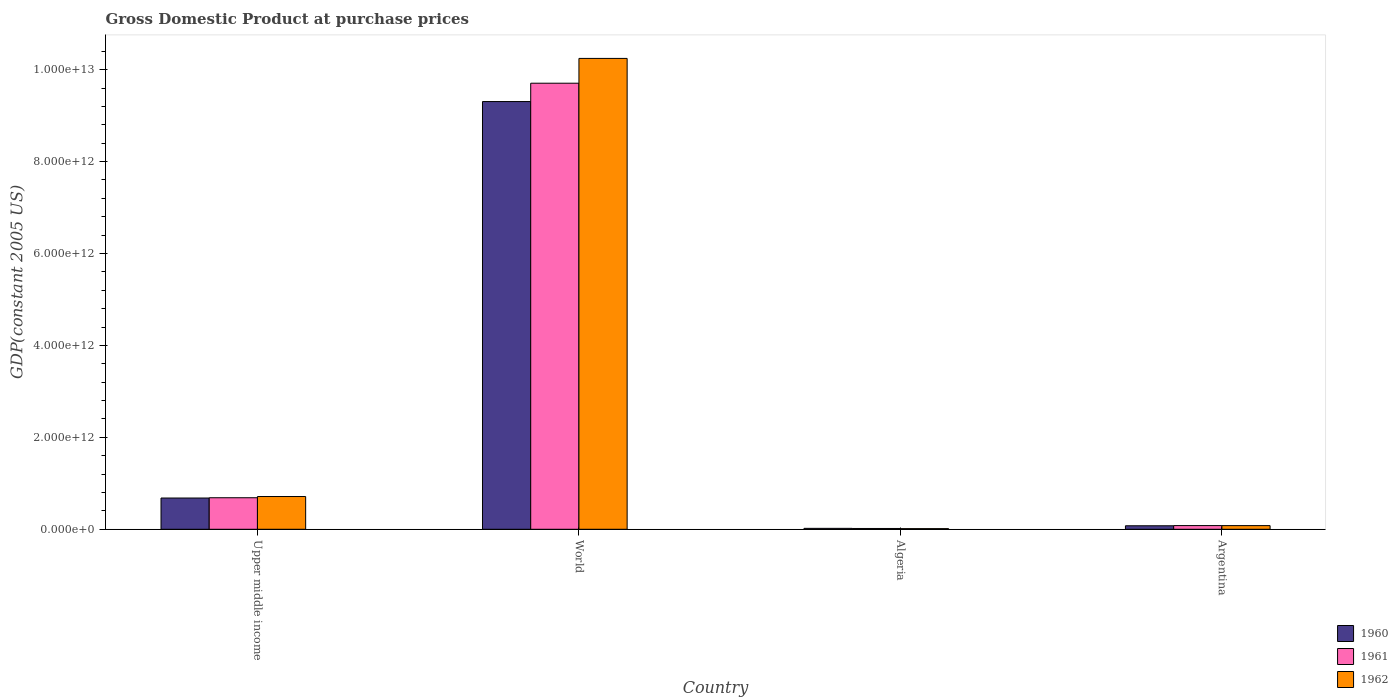How many groups of bars are there?
Offer a very short reply. 4. Are the number of bars per tick equal to the number of legend labels?
Give a very brief answer. Yes. In how many cases, is the number of bars for a given country not equal to the number of legend labels?
Provide a succinct answer. 0. What is the GDP at purchase prices in 1961 in World?
Provide a short and direct response. 9.71e+12. Across all countries, what is the maximum GDP at purchase prices in 1962?
Give a very brief answer. 1.02e+13. Across all countries, what is the minimum GDP at purchase prices in 1961?
Offer a terse response. 1.72e+1. In which country was the GDP at purchase prices in 1960 maximum?
Your answer should be compact. World. In which country was the GDP at purchase prices in 1960 minimum?
Make the answer very short. Algeria. What is the total GDP at purchase prices in 1961 in the graph?
Ensure brevity in your answer.  1.05e+13. What is the difference between the GDP at purchase prices in 1960 in Algeria and that in World?
Your answer should be very brief. -9.29e+12. What is the difference between the GDP at purchase prices in 1961 in Upper middle income and the GDP at purchase prices in 1960 in World?
Ensure brevity in your answer.  -8.62e+12. What is the average GDP at purchase prices in 1962 per country?
Your response must be concise. 2.76e+12. What is the difference between the GDP at purchase prices of/in 1960 and GDP at purchase prices of/in 1961 in Argentina?
Provide a succinct answer. -4.14e+09. In how many countries, is the GDP at purchase prices in 1962 greater than 2800000000000 US$?
Your answer should be very brief. 1. What is the ratio of the GDP at purchase prices in 1962 in Argentina to that in World?
Provide a succinct answer. 0.01. What is the difference between the highest and the second highest GDP at purchase prices in 1962?
Your answer should be compact. 1.02e+13. What is the difference between the highest and the lowest GDP at purchase prices in 1960?
Offer a very short reply. 9.29e+12. In how many countries, is the GDP at purchase prices in 1960 greater than the average GDP at purchase prices in 1960 taken over all countries?
Make the answer very short. 1. What is the difference between two consecutive major ticks on the Y-axis?
Your answer should be compact. 2.00e+12. Does the graph contain any zero values?
Offer a terse response. No. How many legend labels are there?
Your answer should be compact. 3. How are the legend labels stacked?
Provide a succinct answer. Vertical. What is the title of the graph?
Offer a very short reply. Gross Domestic Product at purchase prices. What is the label or title of the Y-axis?
Provide a succinct answer. GDP(constant 2005 US). What is the GDP(constant 2005 US) in 1960 in Upper middle income?
Offer a terse response. 6.80e+11. What is the GDP(constant 2005 US) of 1961 in Upper middle income?
Provide a succinct answer. 6.86e+11. What is the GDP(constant 2005 US) in 1962 in Upper middle income?
Provide a short and direct response. 7.13e+11. What is the GDP(constant 2005 US) of 1960 in World?
Your response must be concise. 9.31e+12. What is the GDP(constant 2005 US) in 1961 in World?
Your answer should be compact. 9.71e+12. What is the GDP(constant 2005 US) in 1962 in World?
Offer a terse response. 1.02e+13. What is the GDP(constant 2005 US) of 1960 in Algeria?
Give a very brief answer. 1.99e+1. What is the GDP(constant 2005 US) of 1961 in Algeria?
Keep it short and to the point. 1.72e+1. What is the GDP(constant 2005 US) of 1962 in Algeria?
Give a very brief answer. 1.38e+1. What is the GDP(constant 2005 US) in 1960 in Argentina?
Your answer should be very brief. 7.63e+1. What is the GDP(constant 2005 US) of 1961 in Argentina?
Provide a succinct answer. 8.04e+1. What is the GDP(constant 2005 US) in 1962 in Argentina?
Your answer should be very brief. 7.97e+1. Across all countries, what is the maximum GDP(constant 2005 US) of 1960?
Give a very brief answer. 9.31e+12. Across all countries, what is the maximum GDP(constant 2005 US) of 1961?
Keep it short and to the point. 9.71e+12. Across all countries, what is the maximum GDP(constant 2005 US) of 1962?
Ensure brevity in your answer.  1.02e+13. Across all countries, what is the minimum GDP(constant 2005 US) of 1960?
Offer a terse response. 1.99e+1. Across all countries, what is the minimum GDP(constant 2005 US) of 1961?
Provide a short and direct response. 1.72e+1. Across all countries, what is the minimum GDP(constant 2005 US) in 1962?
Provide a short and direct response. 1.38e+1. What is the total GDP(constant 2005 US) of 1960 in the graph?
Keep it short and to the point. 1.01e+13. What is the total GDP(constant 2005 US) of 1961 in the graph?
Your answer should be compact. 1.05e+13. What is the total GDP(constant 2005 US) of 1962 in the graph?
Give a very brief answer. 1.11e+13. What is the difference between the GDP(constant 2005 US) in 1960 in Upper middle income and that in World?
Make the answer very short. -8.63e+12. What is the difference between the GDP(constant 2005 US) in 1961 in Upper middle income and that in World?
Your answer should be compact. -9.02e+12. What is the difference between the GDP(constant 2005 US) of 1962 in Upper middle income and that in World?
Give a very brief answer. -9.53e+12. What is the difference between the GDP(constant 2005 US) of 1960 in Upper middle income and that in Algeria?
Make the answer very short. 6.60e+11. What is the difference between the GDP(constant 2005 US) in 1961 in Upper middle income and that in Algeria?
Provide a succinct answer. 6.69e+11. What is the difference between the GDP(constant 2005 US) of 1962 in Upper middle income and that in Algeria?
Your response must be concise. 6.99e+11. What is the difference between the GDP(constant 2005 US) in 1960 in Upper middle income and that in Argentina?
Offer a very short reply. 6.04e+11. What is the difference between the GDP(constant 2005 US) of 1961 in Upper middle income and that in Argentina?
Make the answer very short. 6.06e+11. What is the difference between the GDP(constant 2005 US) of 1962 in Upper middle income and that in Argentina?
Offer a terse response. 6.33e+11. What is the difference between the GDP(constant 2005 US) in 1960 in World and that in Algeria?
Provide a succinct answer. 9.29e+12. What is the difference between the GDP(constant 2005 US) in 1961 in World and that in Algeria?
Your response must be concise. 9.69e+12. What is the difference between the GDP(constant 2005 US) of 1962 in World and that in Algeria?
Ensure brevity in your answer.  1.02e+13. What is the difference between the GDP(constant 2005 US) in 1960 in World and that in Argentina?
Offer a terse response. 9.23e+12. What is the difference between the GDP(constant 2005 US) of 1961 in World and that in Argentina?
Provide a succinct answer. 9.63e+12. What is the difference between the GDP(constant 2005 US) of 1962 in World and that in Argentina?
Offer a very short reply. 1.02e+13. What is the difference between the GDP(constant 2005 US) in 1960 in Algeria and that in Argentina?
Make the answer very short. -5.63e+1. What is the difference between the GDP(constant 2005 US) of 1961 in Algeria and that in Argentina?
Provide a short and direct response. -6.32e+1. What is the difference between the GDP(constant 2005 US) of 1962 in Algeria and that in Argentina?
Give a very brief answer. -6.59e+1. What is the difference between the GDP(constant 2005 US) in 1960 in Upper middle income and the GDP(constant 2005 US) in 1961 in World?
Offer a terse response. -9.03e+12. What is the difference between the GDP(constant 2005 US) in 1960 in Upper middle income and the GDP(constant 2005 US) in 1962 in World?
Your answer should be very brief. -9.56e+12. What is the difference between the GDP(constant 2005 US) in 1961 in Upper middle income and the GDP(constant 2005 US) in 1962 in World?
Your response must be concise. -9.56e+12. What is the difference between the GDP(constant 2005 US) in 1960 in Upper middle income and the GDP(constant 2005 US) in 1961 in Algeria?
Ensure brevity in your answer.  6.63e+11. What is the difference between the GDP(constant 2005 US) in 1960 in Upper middle income and the GDP(constant 2005 US) in 1962 in Algeria?
Provide a succinct answer. 6.66e+11. What is the difference between the GDP(constant 2005 US) of 1961 in Upper middle income and the GDP(constant 2005 US) of 1962 in Algeria?
Provide a succinct answer. 6.72e+11. What is the difference between the GDP(constant 2005 US) of 1960 in Upper middle income and the GDP(constant 2005 US) of 1961 in Argentina?
Give a very brief answer. 6.00e+11. What is the difference between the GDP(constant 2005 US) of 1960 in Upper middle income and the GDP(constant 2005 US) of 1962 in Argentina?
Offer a terse response. 6.00e+11. What is the difference between the GDP(constant 2005 US) in 1961 in Upper middle income and the GDP(constant 2005 US) in 1962 in Argentina?
Provide a succinct answer. 6.06e+11. What is the difference between the GDP(constant 2005 US) of 1960 in World and the GDP(constant 2005 US) of 1961 in Algeria?
Your answer should be compact. 9.29e+12. What is the difference between the GDP(constant 2005 US) in 1960 in World and the GDP(constant 2005 US) in 1962 in Algeria?
Give a very brief answer. 9.29e+12. What is the difference between the GDP(constant 2005 US) in 1961 in World and the GDP(constant 2005 US) in 1962 in Algeria?
Provide a short and direct response. 9.69e+12. What is the difference between the GDP(constant 2005 US) in 1960 in World and the GDP(constant 2005 US) in 1961 in Argentina?
Provide a short and direct response. 9.23e+12. What is the difference between the GDP(constant 2005 US) of 1960 in World and the GDP(constant 2005 US) of 1962 in Argentina?
Make the answer very short. 9.23e+12. What is the difference between the GDP(constant 2005 US) in 1961 in World and the GDP(constant 2005 US) in 1962 in Argentina?
Keep it short and to the point. 9.63e+12. What is the difference between the GDP(constant 2005 US) of 1960 in Algeria and the GDP(constant 2005 US) of 1961 in Argentina?
Give a very brief answer. -6.05e+1. What is the difference between the GDP(constant 2005 US) of 1960 in Algeria and the GDP(constant 2005 US) of 1962 in Argentina?
Offer a very short reply. -5.98e+1. What is the difference between the GDP(constant 2005 US) in 1961 in Algeria and the GDP(constant 2005 US) in 1962 in Argentina?
Offer a terse response. -6.25e+1. What is the average GDP(constant 2005 US) of 1960 per country?
Ensure brevity in your answer.  2.52e+12. What is the average GDP(constant 2005 US) in 1961 per country?
Your answer should be very brief. 2.62e+12. What is the average GDP(constant 2005 US) of 1962 per country?
Your answer should be very brief. 2.76e+12. What is the difference between the GDP(constant 2005 US) of 1960 and GDP(constant 2005 US) of 1961 in Upper middle income?
Keep it short and to the point. -6.01e+09. What is the difference between the GDP(constant 2005 US) of 1960 and GDP(constant 2005 US) of 1962 in Upper middle income?
Provide a succinct answer. -3.26e+1. What is the difference between the GDP(constant 2005 US) in 1961 and GDP(constant 2005 US) in 1962 in Upper middle income?
Your answer should be very brief. -2.66e+1. What is the difference between the GDP(constant 2005 US) in 1960 and GDP(constant 2005 US) in 1961 in World?
Provide a short and direct response. -3.99e+11. What is the difference between the GDP(constant 2005 US) of 1960 and GDP(constant 2005 US) of 1962 in World?
Your answer should be very brief. -9.39e+11. What is the difference between the GDP(constant 2005 US) of 1961 and GDP(constant 2005 US) of 1962 in World?
Your answer should be very brief. -5.39e+11. What is the difference between the GDP(constant 2005 US) of 1960 and GDP(constant 2005 US) of 1961 in Algeria?
Make the answer very short. 2.71e+09. What is the difference between the GDP(constant 2005 US) in 1960 and GDP(constant 2005 US) in 1962 in Algeria?
Offer a very short reply. 6.10e+09. What is the difference between the GDP(constant 2005 US) in 1961 and GDP(constant 2005 US) in 1962 in Algeria?
Ensure brevity in your answer.  3.39e+09. What is the difference between the GDP(constant 2005 US) in 1960 and GDP(constant 2005 US) in 1961 in Argentina?
Give a very brief answer. -4.14e+09. What is the difference between the GDP(constant 2005 US) in 1960 and GDP(constant 2005 US) in 1962 in Argentina?
Your response must be concise. -3.45e+09. What is the difference between the GDP(constant 2005 US) in 1961 and GDP(constant 2005 US) in 1962 in Argentina?
Your response must be concise. 6.85e+08. What is the ratio of the GDP(constant 2005 US) in 1960 in Upper middle income to that in World?
Your answer should be compact. 0.07. What is the ratio of the GDP(constant 2005 US) in 1961 in Upper middle income to that in World?
Your response must be concise. 0.07. What is the ratio of the GDP(constant 2005 US) of 1962 in Upper middle income to that in World?
Your response must be concise. 0.07. What is the ratio of the GDP(constant 2005 US) in 1960 in Upper middle income to that in Algeria?
Ensure brevity in your answer.  34.15. What is the ratio of the GDP(constant 2005 US) of 1961 in Upper middle income to that in Algeria?
Provide a succinct answer. 39.88. What is the ratio of the GDP(constant 2005 US) in 1962 in Upper middle income to that in Algeria?
Give a very brief answer. 51.58. What is the ratio of the GDP(constant 2005 US) in 1960 in Upper middle income to that in Argentina?
Keep it short and to the point. 8.92. What is the ratio of the GDP(constant 2005 US) in 1961 in Upper middle income to that in Argentina?
Provide a succinct answer. 8.53. What is the ratio of the GDP(constant 2005 US) of 1962 in Upper middle income to that in Argentina?
Give a very brief answer. 8.94. What is the ratio of the GDP(constant 2005 US) of 1960 in World to that in Algeria?
Ensure brevity in your answer.  467.37. What is the ratio of the GDP(constant 2005 US) in 1961 in World to that in Algeria?
Your response must be concise. 564.18. What is the ratio of the GDP(constant 2005 US) of 1962 in World to that in Algeria?
Provide a short and direct response. 741.5. What is the ratio of the GDP(constant 2005 US) in 1960 in World to that in Argentina?
Keep it short and to the point. 122.04. What is the ratio of the GDP(constant 2005 US) in 1961 in World to that in Argentina?
Your response must be concise. 120.73. What is the ratio of the GDP(constant 2005 US) of 1962 in World to that in Argentina?
Your answer should be compact. 128.53. What is the ratio of the GDP(constant 2005 US) of 1960 in Algeria to that in Argentina?
Your answer should be compact. 0.26. What is the ratio of the GDP(constant 2005 US) in 1961 in Algeria to that in Argentina?
Offer a terse response. 0.21. What is the ratio of the GDP(constant 2005 US) of 1962 in Algeria to that in Argentina?
Provide a succinct answer. 0.17. What is the difference between the highest and the second highest GDP(constant 2005 US) of 1960?
Offer a terse response. 8.63e+12. What is the difference between the highest and the second highest GDP(constant 2005 US) in 1961?
Make the answer very short. 9.02e+12. What is the difference between the highest and the second highest GDP(constant 2005 US) of 1962?
Provide a short and direct response. 9.53e+12. What is the difference between the highest and the lowest GDP(constant 2005 US) of 1960?
Make the answer very short. 9.29e+12. What is the difference between the highest and the lowest GDP(constant 2005 US) of 1961?
Your answer should be very brief. 9.69e+12. What is the difference between the highest and the lowest GDP(constant 2005 US) of 1962?
Your response must be concise. 1.02e+13. 